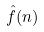<formula> <loc_0><loc_0><loc_500><loc_500>\hat { f } ( n )</formula> 